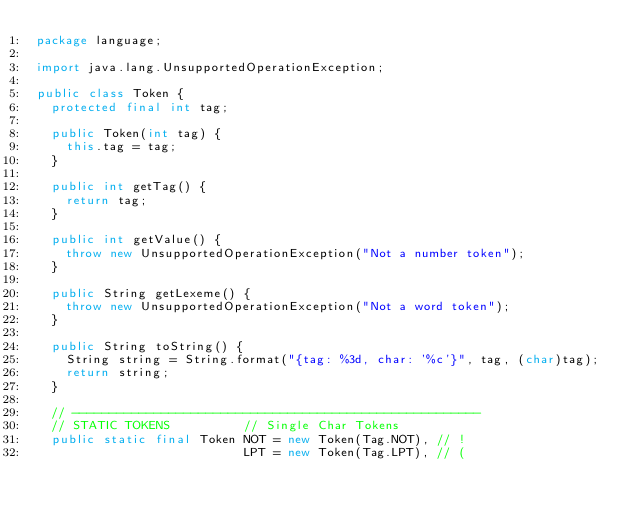Convert code to text. <code><loc_0><loc_0><loc_500><loc_500><_Java_>package language;

import java.lang.UnsupportedOperationException;

public class Token {
  protected final int tag;

  public Token(int tag) {
    this.tag = tag;
  }

  public int getTag() {
    return tag;
  }

  public int getValue() {
    throw new UnsupportedOperationException("Not a number token");
  }

  public String getLexeme() {
    throw new UnsupportedOperationException("Not a word token");
  }

  public String toString() {
    String string = String.format("{tag: %3d, char: '%c'}", tag, (char)tag);
    return string;
  }

  // -------------------------------------------------------
  // STATIC TOKENS          // Single Char Tokens
  public static final Token NOT = new Token(Tag.NOT), // !
                            LPT = new Token(Tag.LPT), // (</code> 